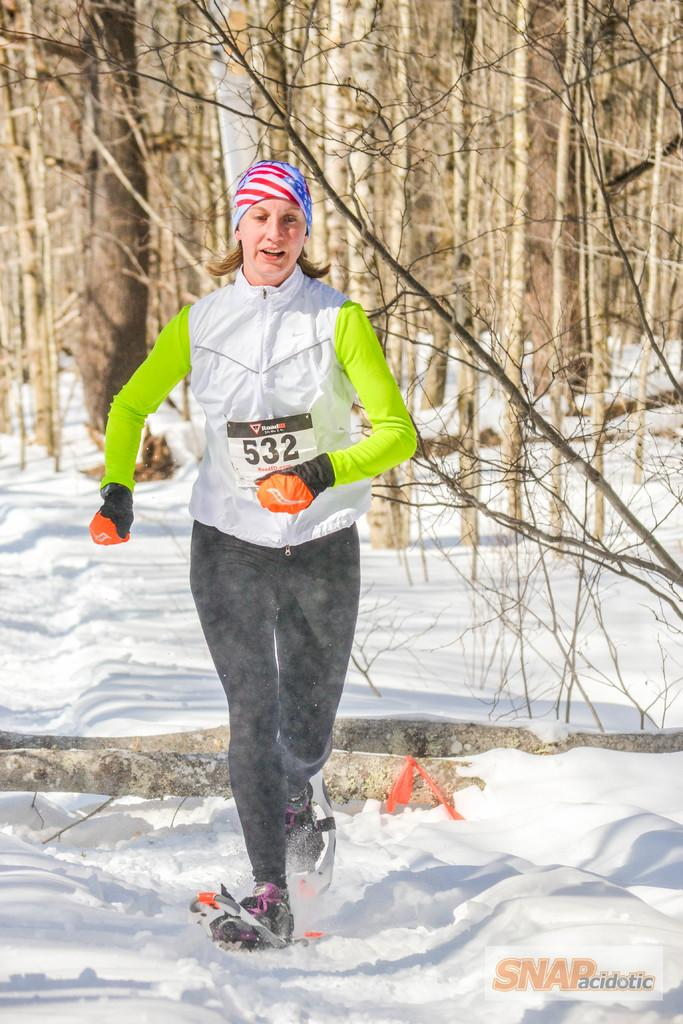Who is the main subject in the image? There is a woman in the image. What is the woman wearing? The woman is wearing a jersey and yoga pants. What activity is the woman engaged in? The woman is running on the snow. What can be seen in the background of the image? There are many trees in the background of the image. What type of star can be seen in the image? There is no star visible in the image; it features a woman running on the snow with trees in the background. 